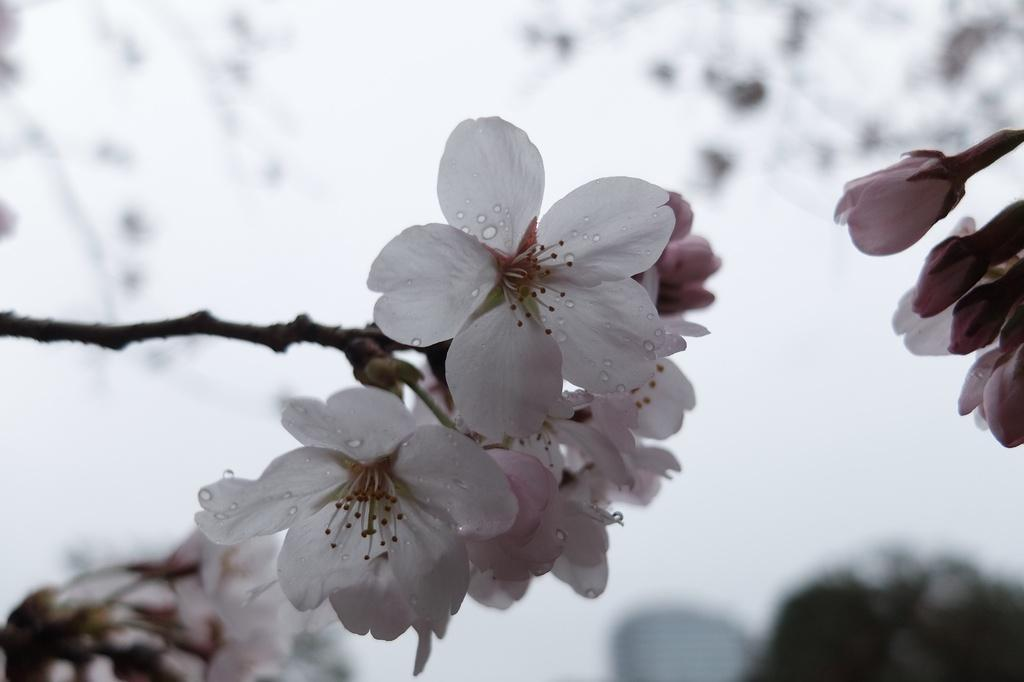What colors are the flowers in the image? The flowers in the image are white and pink. What can be seen on the petals of the flowers? The flowers have water droplets on their petals. What part of the flowers are not visible in the image? The stems of the flowers are not visible in the image. How many giraffes can be seen grazing among the flowers in the image? There are no giraffes present in the image; it features only flowers. What type of steel structure is visible in the image? There is no steel structure present in the image. 